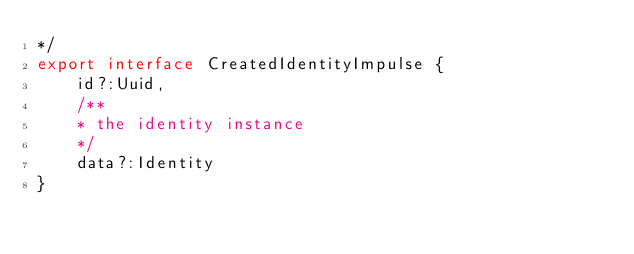<code> <loc_0><loc_0><loc_500><loc_500><_TypeScript_>*/
export interface CreatedIdentityImpulse {
    id?:Uuid, 
    /**
    * the identity instance
    */
    data?:Identity
}</code> 